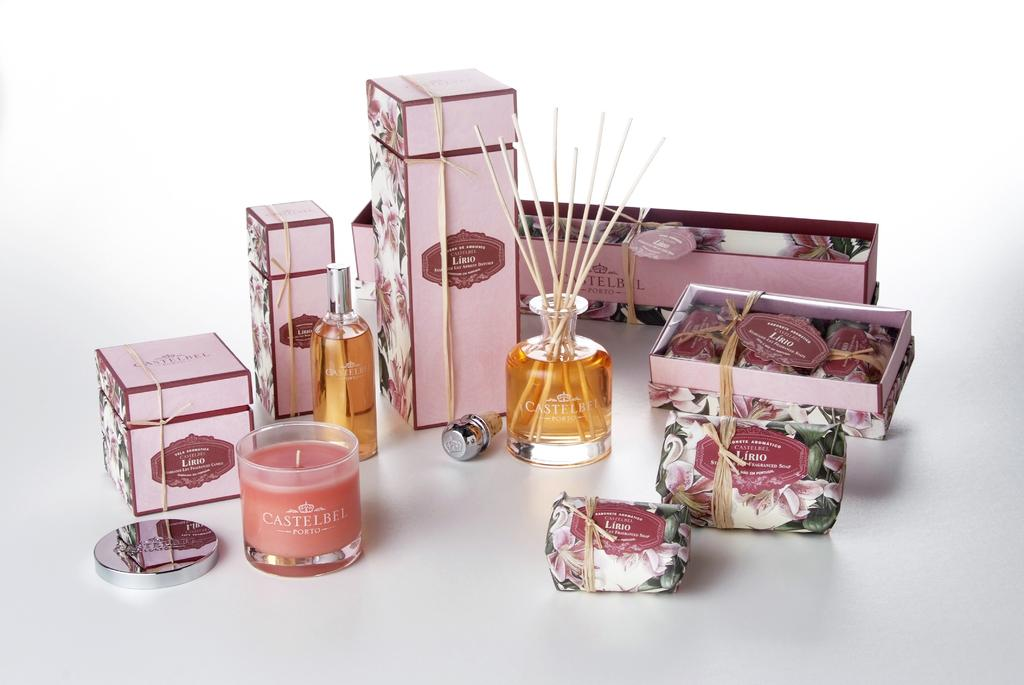<image>
Relay a brief, clear account of the picture shown. A bunch of in-scents and candles. The brand is Castelbel Porto on it. 